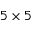Convert formula to latex. <formula><loc_0><loc_0><loc_500><loc_500>5 \times 5</formula> 